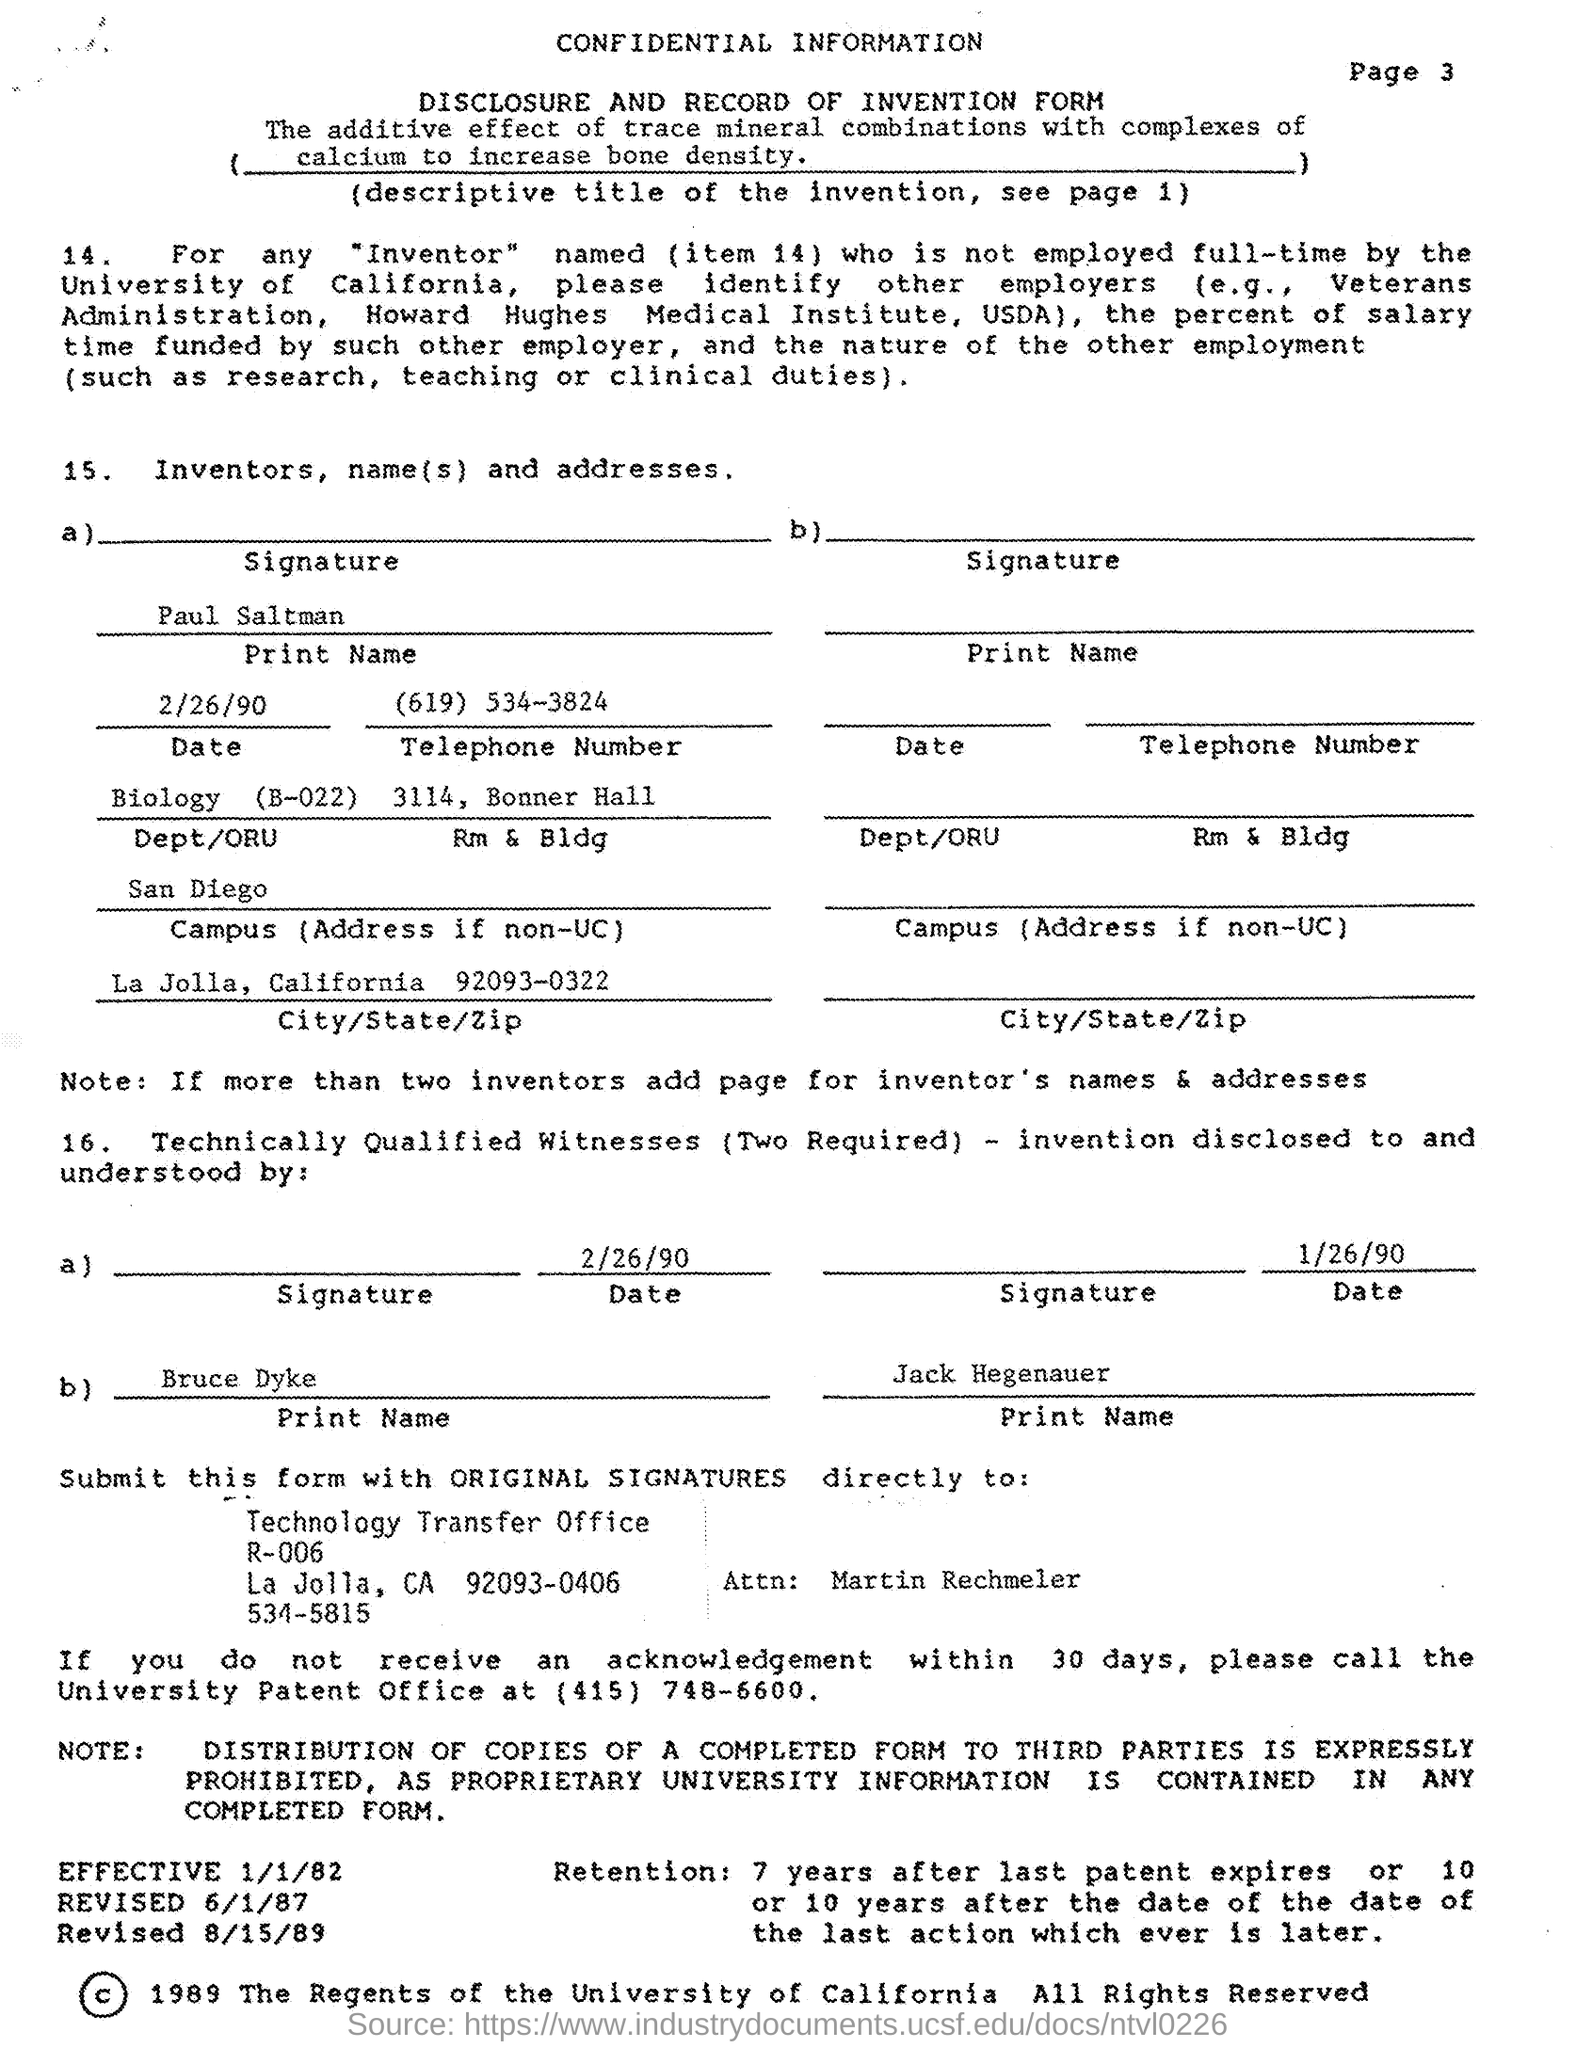Highlight a few significant elements in this photo. The department mentioned in the given form is Biology (B-022). The telephone number mentioned in the given form is (619) 534-3824. The state mentioned in the given form is California. The campus mentioned in the given form is San Diego. The city mentioned in the given form is La Jolla. 